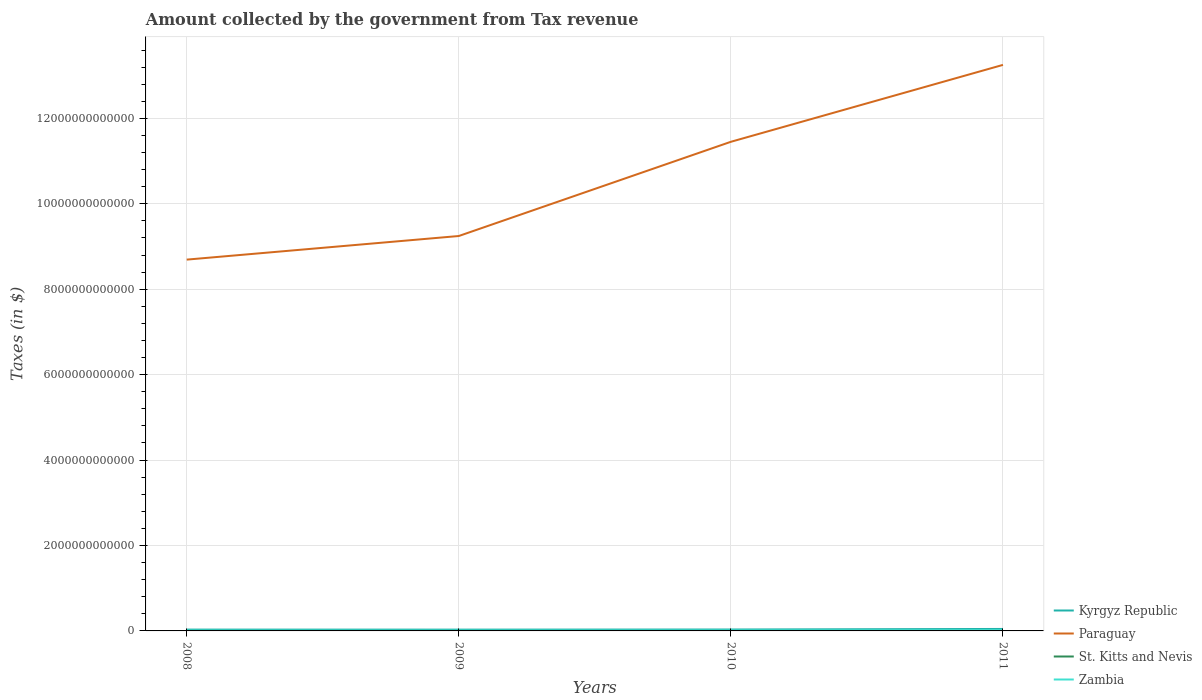Across all years, what is the maximum amount collected by the government from tax revenue in Zambia?
Give a very brief answer. 9.54e+09. What is the total amount collected by the government from tax revenue in Paraguay in the graph?
Give a very brief answer. -5.53e+11. What is the difference between the highest and the second highest amount collected by the government from tax revenue in Paraguay?
Ensure brevity in your answer.  4.56e+12. Is the amount collected by the government from tax revenue in Kyrgyz Republic strictly greater than the amount collected by the government from tax revenue in Zambia over the years?
Offer a terse response. No. How many lines are there?
Provide a succinct answer. 4. What is the difference between two consecutive major ticks on the Y-axis?
Your response must be concise. 2.00e+12. Are the values on the major ticks of Y-axis written in scientific E-notation?
Offer a very short reply. No. Does the graph contain any zero values?
Your response must be concise. No. Where does the legend appear in the graph?
Your answer should be very brief. Bottom right. How many legend labels are there?
Your response must be concise. 4. How are the legend labels stacked?
Provide a short and direct response. Vertical. What is the title of the graph?
Keep it short and to the point. Amount collected by the government from Tax revenue. Does "Costa Rica" appear as one of the legend labels in the graph?
Ensure brevity in your answer.  No. What is the label or title of the Y-axis?
Ensure brevity in your answer.  Taxes (in $). What is the Taxes (in $) in Kyrgyz Republic in 2008?
Offer a very short reply. 3.10e+1. What is the Taxes (in $) in Paraguay in 2008?
Your answer should be very brief. 8.69e+12. What is the Taxes (in $) of St. Kitts and Nevis in 2008?
Keep it short and to the point. 4.21e+08. What is the Taxes (in $) in Zambia in 2008?
Offer a terse response. 9.54e+09. What is the Taxes (in $) of Kyrgyz Republic in 2009?
Offer a terse response. 3.03e+1. What is the Taxes (in $) of Paraguay in 2009?
Provide a short and direct response. 9.25e+12. What is the Taxes (in $) of St. Kitts and Nevis in 2009?
Offer a very short reply. 3.94e+08. What is the Taxes (in $) in Zambia in 2009?
Ensure brevity in your answer.  9.67e+09. What is the Taxes (in $) in Kyrgyz Republic in 2010?
Provide a succinct answer. 3.31e+1. What is the Taxes (in $) of Paraguay in 2010?
Your answer should be compact. 1.15e+13. What is the Taxes (in $) of St. Kitts and Nevis in 2010?
Keep it short and to the point. 3.43e+08. What is the Taxes (in $) of Zambia in 2010?
Your answer should be compact. 1.29e+1. What is the Taxes (in $) of Kyrgyz Republic in 2011?
Make the answer very short. 4.61e+1. What is the Taxes (in $) in Paraguay in 2011?
Ensure brevity in your answer.  1.33e+13. What is the Taxes (in $) in St. Kitts and Nevis in 2011?
Your response must be concise. 4.08e+08. What is the Taxes (in $) of Zambia in 2011?
Give a very brief answer. 1.84e+1. Across all years, what is the maximum Taxes (in $) in Kyrgyz Republic?
Offer a very short reply. 4.61e+1. Across all years, what is the maximum Taxes (in $) of Paraguay?
Provide a succinct answer. 1.33e+13. Across all years, what is the maximum Taxes (in $) in St. Kitts and Nevis?
Offer a very short reply. 4.21e+08. Across all years, what is the maximum Taxes (in $) of Zambia?
Your answer should be very brief. 1.84e+1. Across all years, what is the minimum Taxes (in $) in Kyrgyz Republic?
Offer a terse response. 3.03e+1. Across all years, what is the minimum Taxes (in $) of Paraguay?
Keep it short and to the point. 8.69e+12. Across all years, what is the minimum Taxes (in $) of St. Kitts and Nevis?
Make the answer very short. 3.43e+08. Across all years, what is the minimum Taxes (in $) of Zambia?
Your response must be concise. 9.54e+09. What is the total Taxes (in $) in Kyrgyz Republic in the graph?
Offer a very short reply. 1.41e+11. What is the total Taxes (in $) in Paraguay in the graph?
Provide a succinct answer. 4.26e+13. What is the total Taxes (in $) in St. Kitts and Nevis in the graph?
Provide a short and direct response. 1.57e+09. What is the total Taxes (in $) in Zambia in the graph?
Provide a succinct answer. 5.05e+1. What is the difference between the Taxes (in $) of Kyrgyz Republic in 2008 and that in 2009?
Make the answer very short. 7.79e+08. What is the difference between the Taxes (in $) in Paraguay in 2008 and that in 2009?
Provide a succinct answer. -5.53e+11. What is the difference between the Taxes (in $) in St. Kitts and Nevis in 2008 and that in 2009?
Give a very brief answer. 2.62e+07. What is the difference between the Taxes (in $) of Zambia in 2008 and that in 2009?
Your answer should be very brief. -1.29e+08. What is the difference between the Taxes (in $) of Kyrgyz Republic in 2008 and that in 2010?
Your answer should be compact. -2.09e+09. What is the difference between the Taxes (in $) of Paraguay in 2008 and that in 2010?
Offer a terse response. -2.76e+12. What is the difference between the Taxes (in $) of St. Kitts and Nevis in 2008 and that in 2010?
Provide a short and direct response. 7.77e+07. What is the difference between the Taxes (in $) of Zambia in 2008 and that in 2010?
Make the answer very short. -3.34e+09. What is the difference between the Taxes (in $) in Kyrgyz Republic in 2008 and that in 2011?
Keep it short and to the point. -1.51e+1. What is the difference between the Taxes (in $) of Paraguay in 2008 and that in 2011?
Offer a very short reply. -4.56e+12. What is the difference between the Taxes (in $) in St. Kitts and Nevis in 2008 and that in 2011?
Your answer should be very brief. 1.27e+07. What is the difference between the Taxes (in $) in Zambia in 2008 and that in 2011?
Your response must be concise. -8.87e+09. What is the difference between the Taxes (in $) of Kyrgyz Republic in 2009 and that in 2010?
Your response must be concise. -2.87e+09. What is the difference between the Taxes (in $) in Paraguay in 2009 and that in 2010?
Your response must be concise. -2.21e+12. What is the difference between the Taxes (in $) of St. Kitts and Nevis in 2009 and that in 2010?
Your response must be concise. 5.15e+07. What is the difference between the Taxes (in $) of Zambia in 2009 and that in 2010?
Provide a short and direct response. -3.21e+09. What is the difference between the Taxes (in $) in Kyrgyz Republic in 2009 and that in 2011?
Offer a very short reply. -1.59e+1. What is the difference between the Taxes (in $) in Paraguay in 2009 and that in 2011?
Provide a succinct answer. -4.01e+12. What is the difference between the Taxes (in $) of St. Kitts and Nevis in 2009 and that in 2011?
Provide a succinct answer. -1.35e+07. What is the difference between the Taxes (in $) of Zambia in 2009 and that in 2011?
Offer a terse response. -8.75e+09. What is the difference between the Taxes (in $) in Kyrgyz Republic in 2010 and that in 2011?
Offer a very short reply. -1.30e+1. What is the difference between the Taxes (in $) of Paraguay in 2010 and that in 2011?
Your answer should be compact. -1.80e+12. What is the difference between the Taxes (in $) of St. Kitts and Nevis in 2010 and that in 2011?
Your answer should be very brief. -6.50e+07. What is the difference between the Taxes (in $) of Zambia in 2010 and that in 2011?
Provide a short and direct response. -5.54e+09. What is the difference between the Taxes (in $) of Kyrgyz Republic in 2008 and the Taxes (in $) of Paraguay in 2009?
Provide a short and direct response. -9.22e+12. What is the difference between the Taxes (in $) of Kyrgyz Republic in 2008 and the Taxes (in $) of St. Kitts and Nevis in 2009?
Ensure brevity in your answer.  3.06e+1. What is the difference between the Taxes (in $) of Kyrgyz Republic in 2008 and the Taxes (in $) of Zambia in 2009?
Keep it short and to the point. 2.14e+1. What is the difference between the Taxes (in $) of Paraguay in 2008 and the Taxes (in $) of St. Kitts and Nevis in 2009?
Ensure brevity in your answer.  8.69e+12. What is the difference between the Taxes (in $) in Paraguay in 2008 and the Taxes (in $) in Zambia in 2009?
Give a very brief answer. 8.68e+12. What is the difference between the Taxes (in $) in St. Kitts and Nevis in 2008 and the Taxes (in $) in Zambia in 2009?
Your answer should be compact. -9.25e+09. What is the difference between the Taxes (in $) of Kyrgyz Republic in 2008 and the Taxes (in $) of Paraguay in 2010?
Keep it short and to the point. -1.14e+13. What is the difference between the Taxes (in $) of Kyrgyz Republic in 2008 and the Taxes (in $) of St. Kitts and Nevis in 2010?
Keep it short and to the point. 3.07e+1. What is the difference between the Taxes (in $) of Kyrgyz Republic in 2008 and the Taxes (in $) of Zambia in 2010?
Keep it short and to the point. 1.82e+1. What is the difference between the Taxes (in $) in Paraguay in 2008 and the Taxes (in $) in St. Kitts and Nevis in 2010?
Offer a very short reply. 8.69e+12. What is the difference between the Taxes (in $) in Paraguay in 2008 and the Taxes (in $) in Zambia in 2010?
Keep it short and to the point. 8.68e+12. What is the difference between the Taxes (in $) of St. Kitts and Nevis in 2008 and the Taxes (in $) of Zambia in 2010?
Offer a terse response. -1.25e+1. What is the difference between the Taxes (in $) in Kyrgyz Republic in 2008 and the Taxes (in $) in Paraguay in 2011?
Offer a very short reply. -1.32e+13. What is the difference between the Taxes (in $) of Kyrgyz Republic in 2008 and the Taxes (in $) of St. Kitts and Nevis in 2011?
Make the answer very short. 3.06e+1. What is the difference between the Taxes (in $) in Kyrgyz Republic in 2008 and the Taxes (in $) in Zambia in 2011?
Keep it short and to the point. 1.26e+1. What is the difference between the Taxes (in $) of Paraguay in 2008 and the Taxes (in $) of St. Kitts and Nevis in 2011?
Keep it short and to the point. 8.69e+12. What is the difference between the Taxes (in $) in Paraguay in 2008 and the Taxes (in $) in Zambia in 2011?
Make the answer very short. 8.67e+12. What is the difference between the Taxes (in $) in St. Kitts and Nevis in 2008 and the Taxes (in $) in Zambia in 2011?
Ensure brevity in your answer.  -1.80e+1. What is the difference between the Taxes (in $) in Kyrgyz Republic in 2009 and the Taxes (in $) in Paraguay in 2010?
Make the answer very short. -1.14e+13. What is the difference between the Taxes (in $) in Kyrgyz Republic in 2009 and the Taxes (in $) in St. Kitts and Nevis in 2010?
Give a very brief answer. 2.99e+1. What is the difference between the Taxes (in $) of Kyrgyz Republic in 2009 and the Taxes (in $) of Zambia in 2010?
Ensure brevity in your answer.  1.74e+1. What is the difference between the Taxes (in $) in Paraguay in 2009 and the Taxes (in $) in St. Kitts and Nevis in 2010?
Ensure brevity in your answer.  9.25e+12. What is the difference between the Taxes (in $) in Paraguay in 2009 and the Taxes (in $) in Zambia in 2010?
Make the answer very short. 9.23e+12. What is the difference between the Taxes (in $) in St. Kitts and Nevis in 2009 and the Taxes (in $) in Zambia in 2010?
Offer a very short reply. -1.25e+1. What is the difference between the Taxes (in $) of Kyrgyz Republic in 2009 and the Taxes (in $) of Paraguay in 2011?
Keep it short and to the point. -1.32e+13. What is the difference between the Taxes (in $) in Kyrgyz Republic in 2009 and the Taxes (in $) in St. Kitts and Nevis in 2011?
Give a very brief answer. 2.98e+1. What is the difference between the Taxes (in $) of Kyrgyz Republic in 2009 and the Taxes (in $) of Zambia in 2011?
Give a very brief answer. 1.18e+1. What is the difference between the Taxes (in $) of Paraguay in 2009 and the Taxes (in $) of St. Kitts and Nevis in 2011?
Your answer should be very brief. 9.25e+12. What is the difference between the Taxes (in $) in Paraguay in 2009 and the Taxes (in $) in Zambia in 2011?
Provide a short and direct response. 9.23e+12. What is the difference between the Taxes (in $) of St. Kitts and Nevis in 2009 and the Taxes (in $) of Zambia in 2011?
Offer a very short reply. -1.80e+1. What is the difference between the Taxes (in $) of Kyrgyz Republic in 2010 and the Taxes (in $) of Paraguay in 2011?
Offer a terse response. -1.32e+13. What is the difference between the Taxes (in $) in Kyrgyz Republic in 2010 and the Taxes (in $) in St. Kitts and Nevis in 2011?
Make the answer very short. 3.27e+1. What is the difference between the Taxes (in $) of Kyrgyz Republic in 2010 and the Taxes (in $) of Zambia in 2011?
Offer a very short reply. 1.47e+1. What is the difference between the Taxes (in $) in Paraguay in 2010 and the Taxes (in $) in St. Kitts and Nevis in 2011?
Provide a short and direct response. 1.15e+13. What is the difference between the Taxes (in $) in Paraguay in 2010 and the Taxes (in $) in Zambia in 2011?
Offer a very short reply. 1.14e+13. What is the difference between the Taxes (in $) of St. Kitts and Nevis in 2010 and the Taxes (in $) of Zambia in 2011?
Your response must be concise. -1.81e+1. What is the average Taxes (in $) of Kyrgyz Republic per year?
Offer a very short reply. 3.51e+1. What is the average Taxes (in $) of Paraguay per year?
Give a very brief answer. 1.07e+13. What is the average Taxes (in $) in St. Kitts and Nevis per year?
Your answer should be compact. 3.92e+08. What is the average Taxes (in $) in Zambia per year?
Your answer should be compact. 1.26e+1. In the year 2008, what is the difference between the Taxes (in $) in Kyrgyz Republic and Taxes (in $) in Paraguay?
Make the answer very short. -8.66e+12. In the year 2008, what is the difference between the Taxes (in $) in Kyrgyz Republic and Taxes (in $) in St. Kitts and Nevis?
Make the answer very short. 3.06e+1. In the year 2008, what is the difference between the Taxes (in $) of Kyrgyz Republic and Taxes (in $) of Zambia?
Ensure brevity in your answer.  2.15e+1. In the year 2008, what is the difference between the Taxes (in $) in Paraguay and Taxes (in $) in St. Kitts and Nevis?
Your response must be concise. 8.69e+12. In the year 2008, what is the difference between the Taxes (in $) in Paraguay and Taxes (in $) in Zambia?
Make the answer very short. 8.68e+12. In the year 2008, what is the difference between the Taxes (in $) of St. Kitts and Nevis and Taxes (in $) of Zambia?
Ensure brevity in your answer.  -9.12e+09. In the year 2009, what is the difference between the Taxes (in $) in Kyrgyz Republic and Taxes (in $) in Paraguay?
Keep it short and to the point. -9.22e+12. In the year 2009, what is the difference between the Taxes (in $) of Kyrgyz Republic and Taxes (in $) of St. Kitts and Nevis?
Provide a short and direct response. 2.99e+1. In the year 2009, what is the difference between the Taxes (in $) of Kyrgyz Republic and Taxes (in $) of Zambia?
Your response must be concise. 2.06e+1. In the year 2009, what is the difference between the Taxes (in $) in Paraguay and Taxes (in $) in St. Kitts and Nevis?
Your answer should be very brief. 9.25e+12. In the year 2009, what is the difference between the Taxes (in $) of Paraguay and Taxes (in $) of Zambia?
Give a very brief answer. 9.24e+12. In the year 2009, what is the difference between the Taxes (in $) in St. Kitts and Nevis and Taxes (in $) in Zambia?
Provide a succinct answer. -9.27e+09. In the year 2010, what is the difference between the Taxes (in $) of Kyrgyz Republic and Taxes (in $) of Paraguay?
Give a very brief answer. -1.14e+13. In the year 2010, what is the difference between the Taxes (in $) of Kyrgyz Republic and Taxes (in $) of St. Kitts and Nevis?
Your answer should be compact. 3.28e+1. In the year 2010, what is the difference between the Taxes (in $) of Kyrgyz Republic and Taxes (in $) of Zambia?
Your response must be concise. 2.02e+1. In the year 2010, what is the difference between the Taxes (in $) of Paraguay and Taxes (in $) of St. Kitts and Nevis?
Your answer should be very brief. 1.15e+13. In the year 2010, what is the difference between the Taxes (in $) of Paraguay and Taxes (in $) of Zambia?
Keep it short and to the point. 1.14e+13. In the year 2010, what is the difference between the Taxes (in $) of St. Kitts and Nevis and Taxes (in $) of Zambia?
Give a very brief answer. -1.25e+1. In the year 2011, what is the difference between the Taxes (in $) of Kyrgyz Republic and Taxes (in $) of Paraguay?
Give a very brief answer. -1.32e+13. In the year 2011, what is the difference between the Taxes (in $) of Kyrgyz Republic and Taxes (in $) of St. Kitts and Nevis?
Your answer should be compact. 4.57e+1. In the year 2011, what is the difference between the Taxes (in $) of Kyrgyz Republic and Taxes (in $) of Zambia?
Offer a terse response. 2.77e+1. In the year 2011, what is the difference between the Taxes (in $) in Paraguay and Taxes (in $) in St. Kitts and Nevis?
Your answer should be compact. 1.33e+13. In the year 2011, what is the difference between the Taxes (in $) of Paraguay and Taxes (in $) of Zambia?
Ensure brevity in your answer.  1.32e+13. In the year 2011, what is the difference between the Taxes (in $) in St. Kitts and Nevis and Taxes (in $) in Zambia?
Keep it short and to the point. -1.80e+1. What is the ratio of the Taxes (in $) in Kyrgyz Republic in 2008 to that in 2009?
Your answer should be compact. 1.03. What is the ratio of the Taxes (in $) of Paraguay in 2008 to that in 2009?
Your answer should be compact. 0.94. What is the ratio of the Taxes (in $) in St. Kitts and Nevis in 2008 to that in 2009?
Your response must be concise. 1.07. What is the ratio of the Taxes (in $) in Zambia in 2008 to that in 2009?
Your answer should be compact. 0.99. What is the ratio of the Taxes (in $) of Kyrgyz Republic in 2008 to that in 2010?
Keep it short and to the point. 0.94. What is the ratio of the Taxes (in $) in Paraguay in 2008 to that in 2010?
Provide a short and direct response. 0.76. What is the ratio of the Taxes (in $) of St. Kitts and Nevis in 2008 to that in 2010?
Offer a terse response. 1.23. What is the ratio of the Taxes (in $) in Zambia in 2008 to that in 2010?
Ensure brevity in your answer.  0.74. What is the ratio of the Taxes (in $) of Kyrgyz Republic in 2008 to that in 2011?
Keep it short and to the point. 0.67. What is the ratio of the Taxes (in $) in Paraguay in 2008 to that in 2011?
Your response must be concise. 0.66. What is the ratio of the Taxes (in $) of St. Kitts and Nevis in 2008 to that in 2011?
Your answer should be very brief. 1.03. What is the ratio of the Taxes (in $) in Zambia in 2008 to that in 2011?
Provide a succinct answer. 0.52. What is the ratio of the Taxes (in $) of Kyrgyz Republic in 2009 to that in 2010?
Provide a short and direct response. 0.91. What is the ratio of the Taxes (in $) in Paraguay in 2009 to that in 2010?
Provide a succinct answer. 0.81. What is the ratio of the Taxes (in $) in St. Kitts and Nevis in 2009 to that in 2010?
Your answer should be compact. 1.15. What is the ratio of the Taxes (in $) of Zambia in 2009 to that in 2010?
Offer a terse response. 0.75. What is the ratio of the Taxes (in $) in Kyrgyz Republic in 2009 to that in 2011?
Provide a succinct answer. 0.66. What is the ratio of the Taxes (in $) in Paraguay in 2009 to that in 2011?
Give a very brief answer. 0.7. What is the ratio of the Taxes (in $) in St. Kitts and Nevis in 2009 to that in 2011?
Offer a very short reply. 0.97. What is the ratio of the Taxes (in $) of Zambia in 2009 to that in 2011?
Provide a succinct answer. 0.53. What is the ratio of the Taxes (in $) in Kyrgyz Republic in 2010 to that in 2011?
Provide a succinct answer. 0.72. What is the ratio of the Taxes (in $) in Paraguay in 2010 to that in 2011?
Make the answer very short. 0.86. What is the ratio of the Taxes (in $) in St. Kitts and Nevis in 2010 to that in 2011?
Provide a short and direct response. 0.84. What is the ratio of the Taxes (in $) in Zambia in 2010 to that in 2011?
Keep it short and to the point. 0.7. What is the difference between the highest and the second highest Taxes (in $) in Kyrgyz Republic?
Your answer should be very brief. 1.30e+1. What is the difference between the highest and the second highest Taxes (in $) in Paraguay?
Offer a terse response. 1.80e+12. What is the difference between the highest and the second highest Taxes (in $) of St. Kitts and Nevis?
Provide a succinct answer. 1.27e+07. What is the difference between the highest and the second highest Taxes (in $) in Zambia?
Make the answer very short. 5.54e+09. What is the difference between the highest and the lowest Taxes (in $) in Kyrgyz Republic?
Ensure brevity in your answer.  1.59e+1. What is the difference between the highest and the lowest Taxes (in $) of Paraguay?
Keep it short and to the point. 4.56e+12. What is the difference between the highest and the lowest Taxes (in $) of St. Kitts and Nevis?
Provide a succinct answer. 7.77e+07. What is the difference between the highest and the lowest Taxes (in $) in Zambia?
Provide a short and direct response. 8.87e+09. 